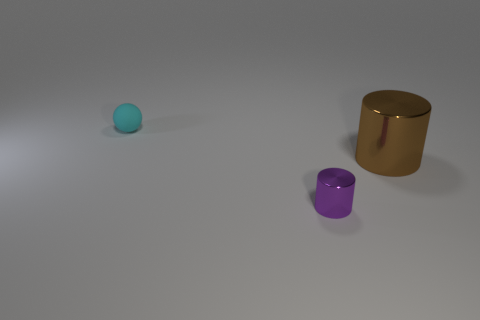There is another object that is the same size as the purple thing; what is its color?
Your answer should be compact. Cyan. Do the brown cylinder and the purple metallic cylinder have the same size?
Offer a very short reply. No. There is a brown cylinder; does it have the same size as the thing in front of the large brown thing?
Ensure brevity in your answer.  No. The thing that is behind the small metallic thing and in front of the small sphere is what color?
Your answer should be very brief. Brown. Are there more tiny metallic things that are left of the large brown object than cyan rubber spheres on the right side of the tiny cyan matte object?
Keep it short and to the point. Yes. There is another object that is the same material as the brown thing; what size is it?
Ensure brevity in your answer.  Small. There is a tiny thing that is in front of the tiny cyan sphere; how many cylinders are behind it?
Offer a very short reply. 1. Is there a big brown object that has the same shape as the purple thing?
Your answer should be compact. Yes. The tiny object that is on the left side of the metallic object left of the big brown metal cylinder is what color?
Make the answer very short. Cyan. Are there more brown cylinders than small gray metallic cubes?
Your answer should be very brief. Yes. 